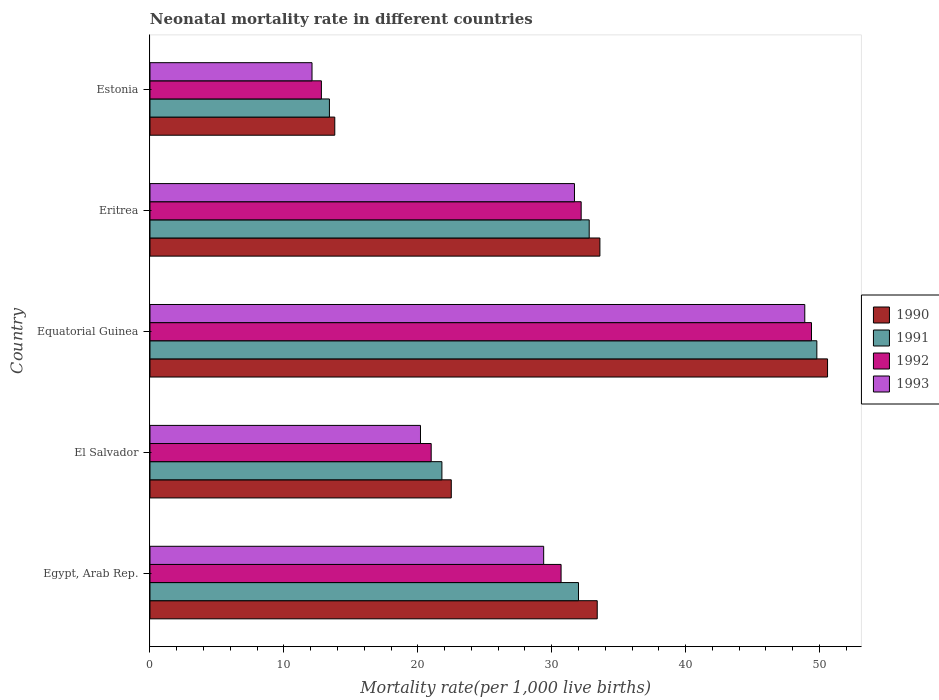Are the number of bars per tick equal to the number of legend labels?
Make the answer very short. Yes. How many bars are there on the 5th tick from the bottom?
Provide a short and direct response. 4. What is the label of the 5th group of bars from the top?
Your response must be concise. Egypt, Arab Rep. What is the neonatal mortality rate in 1992 in Eritrea?
Offer a terse response. 32.2. Across all countries, what is the maximum neonatal mortality rate in 1993?
Offer a very short reply. 48.9. In which country was the neonatal mortality rate in 1990 maximum?
Give a very brief answer. Equatorial Guinea. In which country was the neonatal mortality rate in 1992 minimum?
Provide a short and direct response. Estonia. What is the total neonatal mortality rate in 1993 in the graph?
Offer a very short reply. 142.3. What is the difference between the neonatal mortality rate in 1993 in El Salvador and that in Equatorial Guinea?
Ensure brevity in your answer.  -28.7. What is the difference between the neonatal mortality rate in 1991 in Eritrea and the neonatal mortality rate in 1990 in Estonia?
Provide a succinct answer. 19. What is the average neonatal mortality rate in 1992 per country?
Ensure brevity in your answer.  29.22. What is the difference between the neonatal mortality rate in 1993 and neonatal mortality rate in 1990 in El Salvador?
Keep it short and to the point. -2.3. What is the ratio of the neonatal mortality rate in 1990 in Equatorial Guinea to that in Estonia?
Offer a terse response. 3.67. What is the difference between the highest and the lowest neonatal mortality rate in 1990?
Your answer should be compact. 36.8. Is the sum of the neonatal mortality rate in 1990 in Eritrea and Estonia greater than the maximum neonatal mortality rate in 1993 across all countries?
Ensure brevity in your answer.  No. What does the 3rd bar from the top in Egypt, Arab Rep. represents?
Offer a very short reply. 1991. How many bars are there?
Provide a short and direct response. 20. How many countries are there in the graph?
Ensure brevity in your answer.  5. Are the values on the major ticks of X-axis written in scientific E-notation?
Offer a very short reply. No. Does the graph contain any zero values?
Your answer should be compact. No. Where does the legend appear in the graph?
Offer a very short reply. Center right. How are the legend labels stacked?
Provide a short and direct response. Vertical. What is the title of the graph?
Provide a succinct answer. Neonatal mortality rate in different countries. Does "1997" appear as one of the legend labels in the graph?
Your answer should be compact. No. What is the label or title of the X-axis?
Offer a very short reply. Mortality rate(per 1,0 live births). What is the Mortality rate(per 1,000 live births) of 1990 in Egypt, Arab Rep.?
Offer a terse response. 33.4. What is the Mortality rate(per 1,000 live births) in 1992 in Egypt, Arab Rep.?
Keep it short and to the point. 30.7. What is the Mortality rate(per 1,000 live births) in 1993 in Egypt, Arab Rep.?
Keep it short and to the point. 29.4. What is the Mortality rate(per 1,000 live births) of 1990 in El Salvador?
Provide a short and direct response. 22.5. What is the Mortality rate(per 1,000 live births) of 1991 in El Salvador?
Your response must be concise. 21.8. What is the Mortality rate(per 1,000 live births) in 1993 in El Salvador?
Your answer should be compact. 20.2. What is the Mortality rate(per 1,000 live births) of 1990 in Equatorial Guinea?
Your answer should be very brief. 50.6. What is the Mortality rate(per 1,000 live births) of 1991 in Equatorial Guinea?
Offer a very short reply. 49.8. What is the Mortality rate(per 1,000 live births) of 1992 in Equatorial Guinea?
Offer a terse response. 49.4. What is the Mortality rate(per 1,000 live births) of 1993 in Equatorial Guinea?
Make the answer very short. 48.9. What is the Mortality rate(per 1,000 live births) of 1990 in Eritrea?
Offer a terse response. 33.6. What is the Mortality rate(per 1,000 live births) in 1991 in Eritrea?
Your answer should be compact. 32.8. What is the Mortality rate(per 1,000 live births) in 1992 in Eritrea?
Offer a terse response. 32.2. What is the Mortality rate(per 1,000 live births) of 1993 in Eritrea?
Offer a very short reply. 31.7. What is the Mortality rate(per 1,000 live births) of 1990 in Estonia?
Offer a terse response. 13.8. What is the Mortality rate(per 1,000 live births) of 1992 in Estonia?
Your answer should be compact. 12.8. Across all countries, what is the maximum Mortality rate(per 1,000 live births) of 1990?
Make the answer very short. 50.6. Across all countries, what is the maximum Mortality rate(per 1,000 live births) in 1991?
Your response must be concise. 49.8. Across all countries, what is the maximum Mortality rate(per 1,000 live births) in 1992?
Provide a succinct answer. 49.4. Across all countries, what is the maximum Mortality rate(per 1,000 live births) in 1993?
Keep it short and to the point. 48.9. Across all countries, what is the minimum Mortality rate(per 1,000 live births) of 1990?
Make the answer very short. 13.8. Across all countries, what is the minimum Mortality rate(per 1,000 live births) in 1992?
Your answer should be very brief. 12.8. Across all countries, what is the minimum Mortality rate(per 1,000 live births) in 1993?
Your response must be concise. 12.1. What is the total Mortality rate(per 1,000 live births) in 1990 in the graph?
Offer a terse response. 153.9. What is the total Mortality rate(per 1,000 live births) of 1991 in the graph?
Provide a succinct answer. 149.8. What is the total Mortality rate(per 1,000 live births) in 1992 in the graph?
Give a very brief answer. 146.1. What is the total Mortality rate(per 1,000 live births) of 1993 in the graph?
Your answer should be compact. 142.3. What is the difference between the Mortality rate(per 1,000 live births) of 1990 in Egypt, Arab Rep. and that in El Salvador?
Make the answer very short. 10.9. What is the difference between the Mortality rate(per 1,000 live births) of 1991 in Egypt, Arab Rep. and that in El Salvador?
Provide a short and direct response. 10.2. What is the difference between the Mortality rate(per 1,000 live births) in 1993 in Egypt, Arab Rep. and that in El Salvador?
Ensure brevity in your answer.  9.2. What is the difference between the Mortality rate(per 1,000 live births) in 1990 in Egypt, Arab Rep. and that in Equatorial Guinea?
Offer a terse response. -17.2. What is the difference between the Mortality rate(per 1,000 live births) of 1991 in Egypt, Arab Rep. and that in Equatorial Guinea?
Your response must be concise. -17.8. What is the difference between the Mortality rate(per 1,000 live births) in 1992 in Egypt, Arab Rep. and that in Equatorial Guinea?
Provide a succinct answer. -18.7. What is the difference between the Mortality rate(per 1,000 live births) in 1993 in Egypt, Arab Rep. and that in Equatorial Guinea?
Offer a very short reply. -19.5. What is the difference between the Mortality rate(per 1,000 live births) in 1990 in Egypt, Arab Rep. and that in Eritrea?
Make the answer very short. -0.2. What is the difference between the Mortality rate(per 1,000 live births) in 1991 in Egypt, Arab Rep. and that in Eritrea?
Offer a very short reply. -0.8. What is the difference between the Mortality rate(per 1,000 live births) of 1992 in Egypt, Arab Rep. and that in Eritrea?
Give a very brief answer. -1.5. What is the difference between the Mortality rate(per 1,000 live births) of 1990 in Egypt, Arab Rep. and that in Estonia?
Give a very brief answer. 19.6. What is the difference between the Mortality rate(per 1,000 live births) in 1992 in Egypt, Arab Rep. and that in Estonia?
Keep it short and to the point. 17.9. What is the difference between the Mortality rate(per 1,000 live births) in 1993 in Egypt, Arab Rep. and that in Estonia?
Keep it short and to the point. 17.3. What is the difference between the Mortality rate(per 1,000 live births) of 1990 in El Salvador and that in Equatorial Guinea?
Keep it short and to the point. -28.1. What is the difference between the Mortality rate(per 1,000 live births) of 1991 in El Salvador and that in Equatorial Guinea?
Ensure brevity in your answer.  -28. What is the difference between the Mortality rate(per 1,000 live births) in 1992 in El Salvador and that in Equatorial Guinea?
Keep it short and to the point. -28.4. What is the difference between the Mortality rate(per 1,000 live births) of 1993 in El Salvador and that in Equatorial Guinea?
Keep it short and to the point. -28.7. What is the difference between the Mortality rate(per 1,000 live births) of 1990 in El Salvador and that in Eritrea?
Keep it short and to the point. -11.1. What is the difference between the Mortality rate(per 1,000 live births) in 1992 in El Salvador and that in Eritrea?
Provide a succinct answer. -11.2. What is the difference between the Mortality rate(per 1,000 live births) of 1993 in El Salvador and that in Eritrea?
Give a very brief answer. -11.5. What is the difference between the Mortality rate(per 1,000 live births) in 1990 in Equatorial Guinea and that in Estonia?
Make the answer very short. 36.8. What is the difference between the Mortality rate(per 1,000 live births) in 1991 in Equatorial Guinea and that in Estonia?
Your answer should be compact. 36.4. What is the difference between the Mortality rate(per 1,000 live births) in 1992 in Equatorial Guinea and that in Estonia?
Keep it short and to the point. 36.6. What is the difference between the Mortality rate(per 1,000 live births) of 1993 in Equatorial Guinea and that in Estonia?
Your answer should be compact. 36.8. What is the difference between the Mortality rate(per 1,000 live births) in 1990 in Eritrea and that in Estonia?
Provide a short and direct response. 19.8. What is the difference between the Mortality rate(per 1,000 live births) in 1992 in Eritrea and that in Estonia?
Your answer should be very brief. 19.4. What is the difference between the Mortality rate(per 1,000 live births) of 1993 in Eritrea and that in Estonia?
Offer a very short reply. 19.6. What is the difference between the Mortality rate(per 1,000 live births) of 1990 in Egypt, Arab Rep. and the Mortality rate(per 1,000 live births) of 1993 in El Salvador?
Ensure brevity in your answer.  13.2. What is the difference between the Mortality rate(per 1,000 live births) of 1991 in Egypt, Arab Rep. and the Mortality rate(per 1,000 live births) of 1993 in El Salvador?
Your response must be concise. 11.8. What is the difference between the Mortality rate(per 1,000 live births) of 1992 in Egypt, Arab Rep. and the Mortality rate(per 1,000 live births) of 1993 in El Salvador?
Your answer should be compact. 10.5. What is the difference between the Mortality rate(per 1,000 live births) of 1990 in Egypt, Arab Rep. and the Mortality rate(per 1,000 live births) of 1991 in Equatorial Guinea?
Your answer should be compact. -16.4. What is the difference between the Mortality rate(per 1,000 live births) of 1990 in Egypt, Arab Rep. and the Mortality rate(per 1,000 live births) of 1993 in Equatorial Guinea?
Provide a succinct answer. -15.5. What is the difference between the Mortality rate(per 1,000 live births) of 1991 in Egypt, Arab Rep. and the Mortality rate(per 1,000 live births) of 1992 in Equatorial Guinea?
Offer a very short reply. -17.4. What is the difference between the Mortality rate(per 1,000 live births) of 1991 in Egypt, Arab Rep. and the Mortality rate(per 1,000 live births) of 1993 in Equatorial Guinea?
Provide a short and direct response. -16.9. What is the difference between the Mortality rate(per 1,000 live births) of 1992 in Egypt, Arab Rep. and the Mortality rate(per 1,000 live births) of 1993 in Equatorial Guinea?
Provide a short and direct response. -18.2. What is the difference between the Mortality rate(per 1,000 live births) of 1991 in Egypt, Arab Rep. and the Mortality rate(per 1,000 live births) of 1992 in Eritrea?
Offer a very short reply. -0.2. What is the difference between the Mortality rate(per 1,000 live births) of 1991 in Egypt, Arab Rep. and the Mortality rate(per 1,000 live births) of 1993 in Eritrea?
Ensure brevity in your answer.  0.3. What is the difference between the Mortality rate(per 1,000 live births) in 1992 in Egypt, Arab Rep. and the Mortality rate(per 1,000 live births) in 1993 in Eritrea?
Provide a succinct answer. -1. What is the difference between the Mortality rate(per 1,000 live births) in 1990 in Egypt, Arab Rep. and the Mortality rate(per 1,000 live births) in 1991 in Estonia?
Provide a short and direct response. 20. What is the difference between the Mortality rate(per 1,000 live births) in 1990 in Egypt, Arab Rep. and the Mortality rate(per 1,000 live births) in 1992 in Estonia?
Your answer should be very brief. 20.6. What is the difference between the Mortality rate(per 1,000 live births) of 1990 in Egypt, Arab Rep. and the Mortality rate(per 1,000 live births) of 1993 in Estonia?
Offer a terse response. 21.3. What is the difference between the Mortality rate(per 1,000 live births) in 1991 in Egypt, Arab Rep. and the Mortality rate(per 1,000 live births) in 1992 in Estonia?
Offer a very short reply. 19.2. What is the difference between the Mortality rate(per 1,000 live births) in 1991 in Egypt, Arab Rep. and the Mortality rate(per 1,000 live births) in 1993 in Estonia?
Offer a very short reply. 19.9. What is the difference between the Mortality rate(per 1,000 live births) of 1990 in El Salvador and the Mortality rate(per 1,000 live births) of 1991 in Equatorial Guinea?
Provide a succinct answer. -27.3. What is the difference between the Mortality rate(per 1,000 live births) in 1990 in El Salvador and the Mortality rate(per 1,000 live births) in 1992 in Equatorial Guinea?
Make the answer very short. -26.9. What is the difference between the Mortality rate(per 1,000 live births) of 1990 in El Salvador and the Mortality rate(per 1,000 live births) of 1993 in Equatorial Guinea?
Make the answer very short. -26.4. What is the difference between the Mortality rate(per 1,000 live births) of 1991 in El Salvador and the Mortality rate(per 1,000 live births) of 1992 in Equatorial Guinea?
Provide a short and direct response. -27.6. What is the difference between the Mortality rate(per 1,000 live births) of 1991 in El Salvador and the Mortality rate(per 1,000 live births) of 1993 in Equatorial Guinea?
Offer a terse response. -27.1. What is the difference between the Mortality rate(per 1,000 live births) in 1992 in El Salvador and the Mortality rate(per 1,000 live births) in 1993 in Equatorial Guinea?
Your answer should be very brief. -27.9. What is the difference between the Mortality rate(per 1,000 live births) in 1990 in El Salvador and the Mortality rate(per 1,000 live births) in 1993 in Eritrea?
Keep it short and to the point. -9.2. What is the difference between the Mortality rate(per 1,000 live births) in 1991 in El Salvador and the Mortality rate(per 1,000 live births) in 1993 in Eritrea?
Ensure brevity in your answer.  -9.9. What is the difference between the Mortality rate(per 1,000 live births) of 1990 in El Salvador and the Mortality rate(per 1,000 live births) of 1991 in Estonia?
Offer a very short reply. 9.1. What is the difference between the Mortality rate(per 1,000 live births) of 1990 in El Salvador and the Mortality rate(per 1,000 live births) of 1993 in Estonia?
Provide a succinct answer. 10.4. What is the difference between the Mortality rate(per 1,000 live births) of 1991 in El Salvador and the Mortality rate(per 1,000 live births) of 1993 in Estonia?
Keep it short and to the point. 9.7. What is the difference between the Mortality rate(per 1,000 live births) of 1992 in El Salvador and the Mortality rate(per 1,000 live births) of 1993 in Estonia?
Provide a short and direct response. 8.9. What is the difference between the Mortality rate(per 1,000 live births) in 1990 in Equatorial Guinea and the Mortality rate(per 1,000 live births) in 1991 in Eritrea?
Keep it short and to the point. 17.8. What is the difference between the Mortality rate(per 1,000 live births) in 1990 in Equatorial Guinea and the Mortality rate(per 1,000 live births) in 1992 in Eritrea?
Your answer should be compact. 18.4. What is the difference between the Mortality rate(per 1,000 live births) of 1990 in Equatorial Guinea and the Mortality rate(per 1,000 live births) of 1993 in Eritrea?
Ensure brevity in your answer.  18.9. What is the difference between the Mortality rate(per 1,000 live births) in 1991 in Equatorial Guinea and the Mortality rate(per 1,000 live births) in 1993 in Eritrea?
Offer a very short reply. 18.1. What is the difference between the Mortality rate(per 1,000 live births) in 1990 in Equatorial Guinea and the Mortality rate(per 1,000 live births) in 1991 in Estonia?
Your answer should be very brief. 37.2. What is the difference between the Mortality rate(per 1,000 live births) in 1990 in Equatorial Guinea and the Mortality rate(per 1,000 live births) in 1992 in Estonia?
Provide a succinct answer. 37.8. What is the difference between the Mortality rate(per 1,000 live births) in 1990 in Equatorial Guinea and the Mortality rate(per 1,000 live births) in 1993 in Estonia?
Ensure brevity in your answer.  38.5. What is the difference between the Mortality rate(per 1,000 live births) of 1991 in Equatorial Guinea and the Mortality rate(per 1,000 live births) of 1992 in Estonia?
Make the answer very short. 37. What is the difference between the Mortality rate(per 1,000 live births) of 1991 in Equatorial Guinea and the Mortality rate(per 1,000 live births) of 1993 in Estonia?
Ensure brevity in your answer.  37.7. What is the difference between the Mortality rate(per 1,000 live births) in 1992 in Equatorial Guinea and the Mortality rate(per 1,000 live births) in 1993 in Estonia?
Provide a short and direct response. 37.3. What is the difference between the Mortality rate(per 1,000 live births) in 1990 in Eritrea and the Mortality rate(per 1,000 live births) in 1991 in Estonia?
Make the answer very short. 20.2. What is the difference between the Mortality rate(per 1,000 live births) in 1990 in Eritrea and the Mortality rate(per 1,000 live births) in 1992 in Estonia?
Your response must be concise. 20.8. What is the difference between the Mortality rate(per 1,000 live births) in 1991 in Eritrea and the Mortality rate(per 1,000 live births) in 1993 in Estonia?
Keep it short and to the point. 20.7. What is the difference between the Mortality rate(per 1,000 live births) of 1992 in Eritrea and the Mortality rate(per 1,000 live births) of 1993 in Estonia?
Offer a terse response. 20.1. What is the average Mortality rate(per 1,000 live births) of 1990 per country?
Offer a terse response. 30.78. What is the average Mortality rate(per 1,000 live births) in 1991 per country?
Give a very brief answer. 29.96. What is the average Mortality rate(per 1,000 live births) in 1992 per country?
Your response must be concise. 29.22. What is the average Mortality rate(per 1,000 live births) in 1993 per country?
Offer a terse response. 28.46. What is the difference between the Mortality rate(per 1,000 live births) of 1990 and Mortality rate(per 1,000 live births) of 1993 in Egypt, Arab Rep.?
Provide a succinct answer. 4. What is the difference between the Mortality rate(per 1,000 live births) in 1991 and Mortality rate(per 1,000 live births) in 1992 in Egypt, Arab Rep.?
Your answer should be compact. 1.3. What is the difference between the Mortality rate(per 1,000 live births) of 1991 and Mortality rate(per 1,000 live births) of 1993 in Egypt, Arab Rep.?
Provide a short and direct response. 2.6. What is the difference between the Mortality rate(per 1,000 live births) of 1992 and Mortality rate(per 1,000 live births) of 1993 in Egypt, Arab Rep.?
Your response must be concise. 1.3. What is the difference between the Mortality rate(per 1,000 live births) in 1991 and Mortality rate(per 1,000 live births) in 1993 in El Salvador?
Keep it short and to the point. 1.6. What is the difference between the Mortality rate(per 1,000 live births) of 1992 and Mortality rate(per 1,000 live births) of 1993 in El Salvador?
Provide a succinct answer. 0.8. What is the difference between the Mortality rate(per 1,000 live births) of 1990 and Mortality rate(per 1,000 live births) of 1991 in Equatorial Guinea?
Provide a succinct answer. 0.8. What is the difference between the Mortality rate(per 1,000 live births) in 1991 and Mortality rate(per 1,000 live births) in 1992 in Equatorial Guinea?
Offer a very short reply. 0.4. What is the difference between the Mortality rate(per 1,000 live births) of 1991 and Mortality rate(per 1,000 live births) of 1993 in Equatorial Guinea?
Provide a short and direct response. 0.9. What is the difference between the Mortality rate(per 1,000 live births) in 1992 and Mortality rate(per 1,000 live births) in 1993 in Equatorial Guinea?
Provide a succinct answer. 0.5. What is the difference between the Mortality rate(per 1,000 live births) in 1990 and Mortality rate(per 1,000 live births) in 1991 in Eritrea?
Give a very brief answer. 0.8. What is the difference between the Mortality rate(per 1,000 live births) in 1991 and Mortality rate(per 1,000 live births) in 1992 in Eritrea?
Ensure brevity in your answer.  0.6. What is the difference between the Mortality rate(per 1,000 live births) of 1990 and Mortality rate(per 1,000 live births) of 1991 in Estonia?
Keep it short and to the point. 0.4. What is the difference between the Mortality rate(per 1,000 live births) in 1990 and Mortality rate(per 1,000 live births) in 1993 in Estonia?
Offer a very short reply. 1.7. What is the difference between the Mortality rate(per 1,000 live births) in 1991 and Mortality rate(per 1,000 live births) in 1992 in Estonia?
Your response must be concise. 0.6. What is the difference between the Mortality rate(per 1,000 live births) of 1992 and Mortality rate(per 1,000 live births) of 1993 in Estonia?
Provide a succinct answer. 0.7. What is the ratio of the Mortality rate(per 1,000 live births) of 1990 in Egypt, Arab Rep. to that in El Salvador?
Offer a very short reply. 1.48. What is the ratio of the Mortality rate(per 1,000 live births) of 1991 in Egypt, Arab Rep. to that in El Salvador?
Ensure brevity in your answer.  1.47. What is the ratio of the Mortality rate(per 1,000 live births) in 1992 in Egypt, Arab Rep. to that in El Salvador?
Provide a short and direct response. 1.46. What is the ratio of the Mortality rate(per 1,000 live births) in 1993 in Egypt, Arab Rep. to that in El Salvador?
Keep it short and to the point. 1.46. What is the ratio of the Mortality rate(per 1,000 live births) of 1990 in Egypt, Arab Rep. to that in Equatorial Guinea?
Provide a succinct answer. 0.66. What is the ratio of the Mortality rate(per 1,000 live births) of 1991 in Egypt, Arab Rep. to that in Equatorial Guinea?
Ensure brevity in your answer.  0.64. What is the ratio of the Mortality rate(per 1,000 live births) of 1992 in Egypt, Arab Rep. to that in Equatorial Guinea?
Offer a terse response. 0.62. What is the ratio of the Mortality rate(per 1,000 live births) of 1993 in Egypt, Arab Rep. to that in Equatorial Guinea?
Ensure brevity in your answer.  0.6. What is the ratio of the Mortality rate(per 1,000 live births) in 1990 in Egypt, Arab Rep. to that in Eritrea?
Your answer should be compact. 0.99. What is the ratio of the Mortality rate(per 1,000 live births) of 1991 in Egypt, Arab Rep. to that in Eritrea?
Make the answer very short. 0.98. What is the ratio of the Mortality rate(per 1,000 live births) in 1992 in Egypt, Arab Rep. to that in Eritrea?
Keep it short and to the point. 0.95. What is the ratio of the Mortality rate(per 1,000 live births) in 1993 in Egypt, Arab Rep. to that in Eritrea?
Provide a succinct answer. 0.93. What is the ratio of the Mortality rate(per 1,000 live births) of 1990 in Egypt, Arab Rep. to that in Estonia?
Offer a very short reply. 2.42. What is the ratio of the Mortality rate(per 1,000 live births) of 1991 in Egypt, Arab Rep. to that in Estonia?
Make the answer very short. 2.39. What is the ratio of the Mortality rate(per 1,000 live births) of 1992 in Egypt, Arab Rep. to that in Estonia?
Ensure brevity in your answer.  2.4. What is the ratio of the Mortality rate(per 1,000 live births) in 1993 in Egypt, Arab Rep. to that in Estonia?
Provide a short and direct response. 2.43. What is the ratio of the Mortality rate(per 1,000 live births) in 1990 in El Salvador to that in Equatorial Guinea?
Ensure brevity in your answer.  0.44. What is the ratio of the Mortality rate(per 1,000 live births) in 1991 in El Salvador to that in Equatorial Guinea?
Give a very brief answer. 0.44. What is the ratio of the Mortality rate(per 1,000 live births) in 1992 in El Salvador to that in Equatorial Guinea?
Offer a terse response. 0.43. What is the ratio of the Mortality rate(per 1,000 live births) of 1993 in El Salvador to that in Equatorial Guinea?
Offer a very short reply. 0.41. What is the ratio of the Mortality rate(per 1,000 live births) of 1990 in El Salvador to that in Eritrea?
Give a very brief answer. 0.67. What is the ratio of the Mortality rate(per 1,000 live births) in 1991 in El Salvador to that in Eritrea?
Provide a succinct answer. 0.66. What is the ratio of the Mortality rate(per 1,000 live births) of 1992 in El Salvador to that in Eritrea?
Give a very brief answer. 0.65. What is the ratio of the Mortality rate(per 1,000 live births) of 1993 in El Salvador to that in Eritrea?
Ensure brevity in your answer.  0.64. What is the ratio of the Mortality rate(per 1,000 live births) in 1990 in El Salvador to that in Estonia?
Your answer should be very brief. 1.63. What is the ratio of the Mortality rate(per 1,000 live births) in 1991 in El Salvador to that in Estonia?
Your answer should be compact. 1.63. What is the ratio of the Mortality rate(per 1,000 live births) of 1992 in El Salvador to that in Estonia?
Your answer should be compact. 1.64. What is the ratio of the Mortality rate(per 1,000 live births) of 1993 in El Salvador to that in Estonia?
Offer a very short reply. 1.67. What is the ratio of the Mortality rate(per 1,000 live births) of 1990 in Equatorial Guinea to that in Eritrea?
Offer a terse response. 1.51. What is the ratio of the Mortality rate(per 1,000 live births) in 1991 in Equatorial Guinea to that in Eritrea?
Ensure brevity in your answer.  1.52. What is the ratio of the Mortality rate(per 1,000 live births) in 1992 in Equatorial Guinea to that in Eritrea?
Make the answer very short. 1.53. What is the ratio of the Mortality rate(per 1,000 live births) in 1993 in Equatorial Guinea to that in Eritrea?
Provide a short and direct response. 1.54. What is the ratio of the Mortality rate(per 1,000 live births) of 1990 in Equatorial Guinea to that in Estonia?
Give a very brief answer. 3.67. What is the ratio of the Mortality rate(per 1,000 live births) of 1991 in Equatorial Guinea to that in Estonia?
Keep it short and to the point. 3.72. What is the ratio of the Mortality rate(per 1,000 live births) of 1992 in Equatorial Guinea to that in Estonia?
Your answer should be very brief. 3.86. What is the ratio of the Mortality rate(per 1,000 live births) of 1993 in Equatorial Guinea to that in Estonia?
Keep it short and to the point. 4.04. What is the ratio of the Mortality rate(per 1,000 live births) of 1990 in Eritrea to that in Estonia?
Offer a terse response. 2.43. What is the ratio of the Mortality rate(per 1,000 live births) in 1991 in Eritrea to that in Estonia?
Make the answer very short. 2.45. What is the ratio of the Mortality rate(per 1,000 live births) of 1992 in Eritrea to that in Estonia?
Your answer should be very brief. 2.52. What is the ratio of the Mortality rate(per 1,000 live births) of 1993 in Eritrea to that in Estonia?
Provide a succinct answer. 2.62. What is the difference between the highest and the second highest Mortality rate(per 1,000 live births) in 1990?
Ensure brevity in your answer.  17. What is the difference between the highest and the second highest Mortality rate(per 1,000 live births) of 1993?
Your response must be concise. 17.2. What is the difference between the highest and the lowest Mortality rate(per 1,000 live births) of 1990?
Your answer should be very brief. 36.8. What is the difference between the highest and the lowest Mortality rate(per 1,000 live births) in 1991?
Your answer should be compact. 36.4. What is the difference between the highest and the lowest Mortality rate(per 1,000 live births) of 1992?
Provide a short and direct response. 36.6. What is the difference between the highest and the lowest Mortality rate(per 1,000 live births) in 1993?
Make the answer very short. 36.8. 